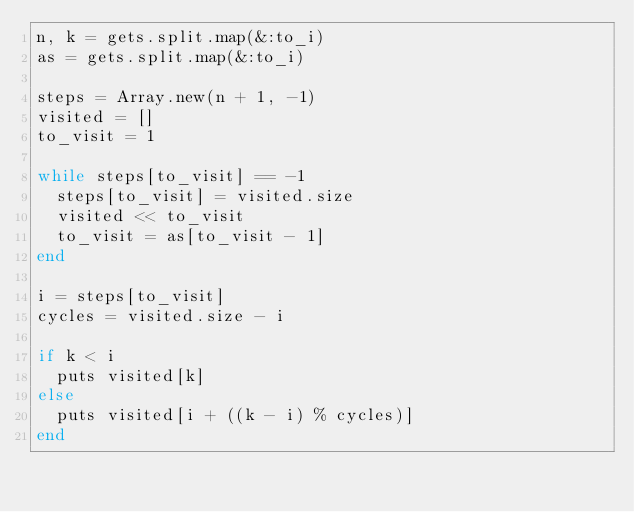Convert code to text. <code><loc_0><loc_0><loc_500><loc_500><_Ruby_>n, k = gets.split.map(&:to_i)
as = gets.split.map(&:to_i)

steps = Array.new(n + 1, -1)
visited = []
to_visit = 1

while steps[to_visit] == -1
  steps[to_visit] = visited.size
  visited << to_visit
  to_visit = as[to_visit - 1]
end

i = steps[to_visit]
cycles = visited.size - i

if k < i
  puts visited[k]
else
  puts visited[i + ((k - i) % cycles)]
end
</code> 